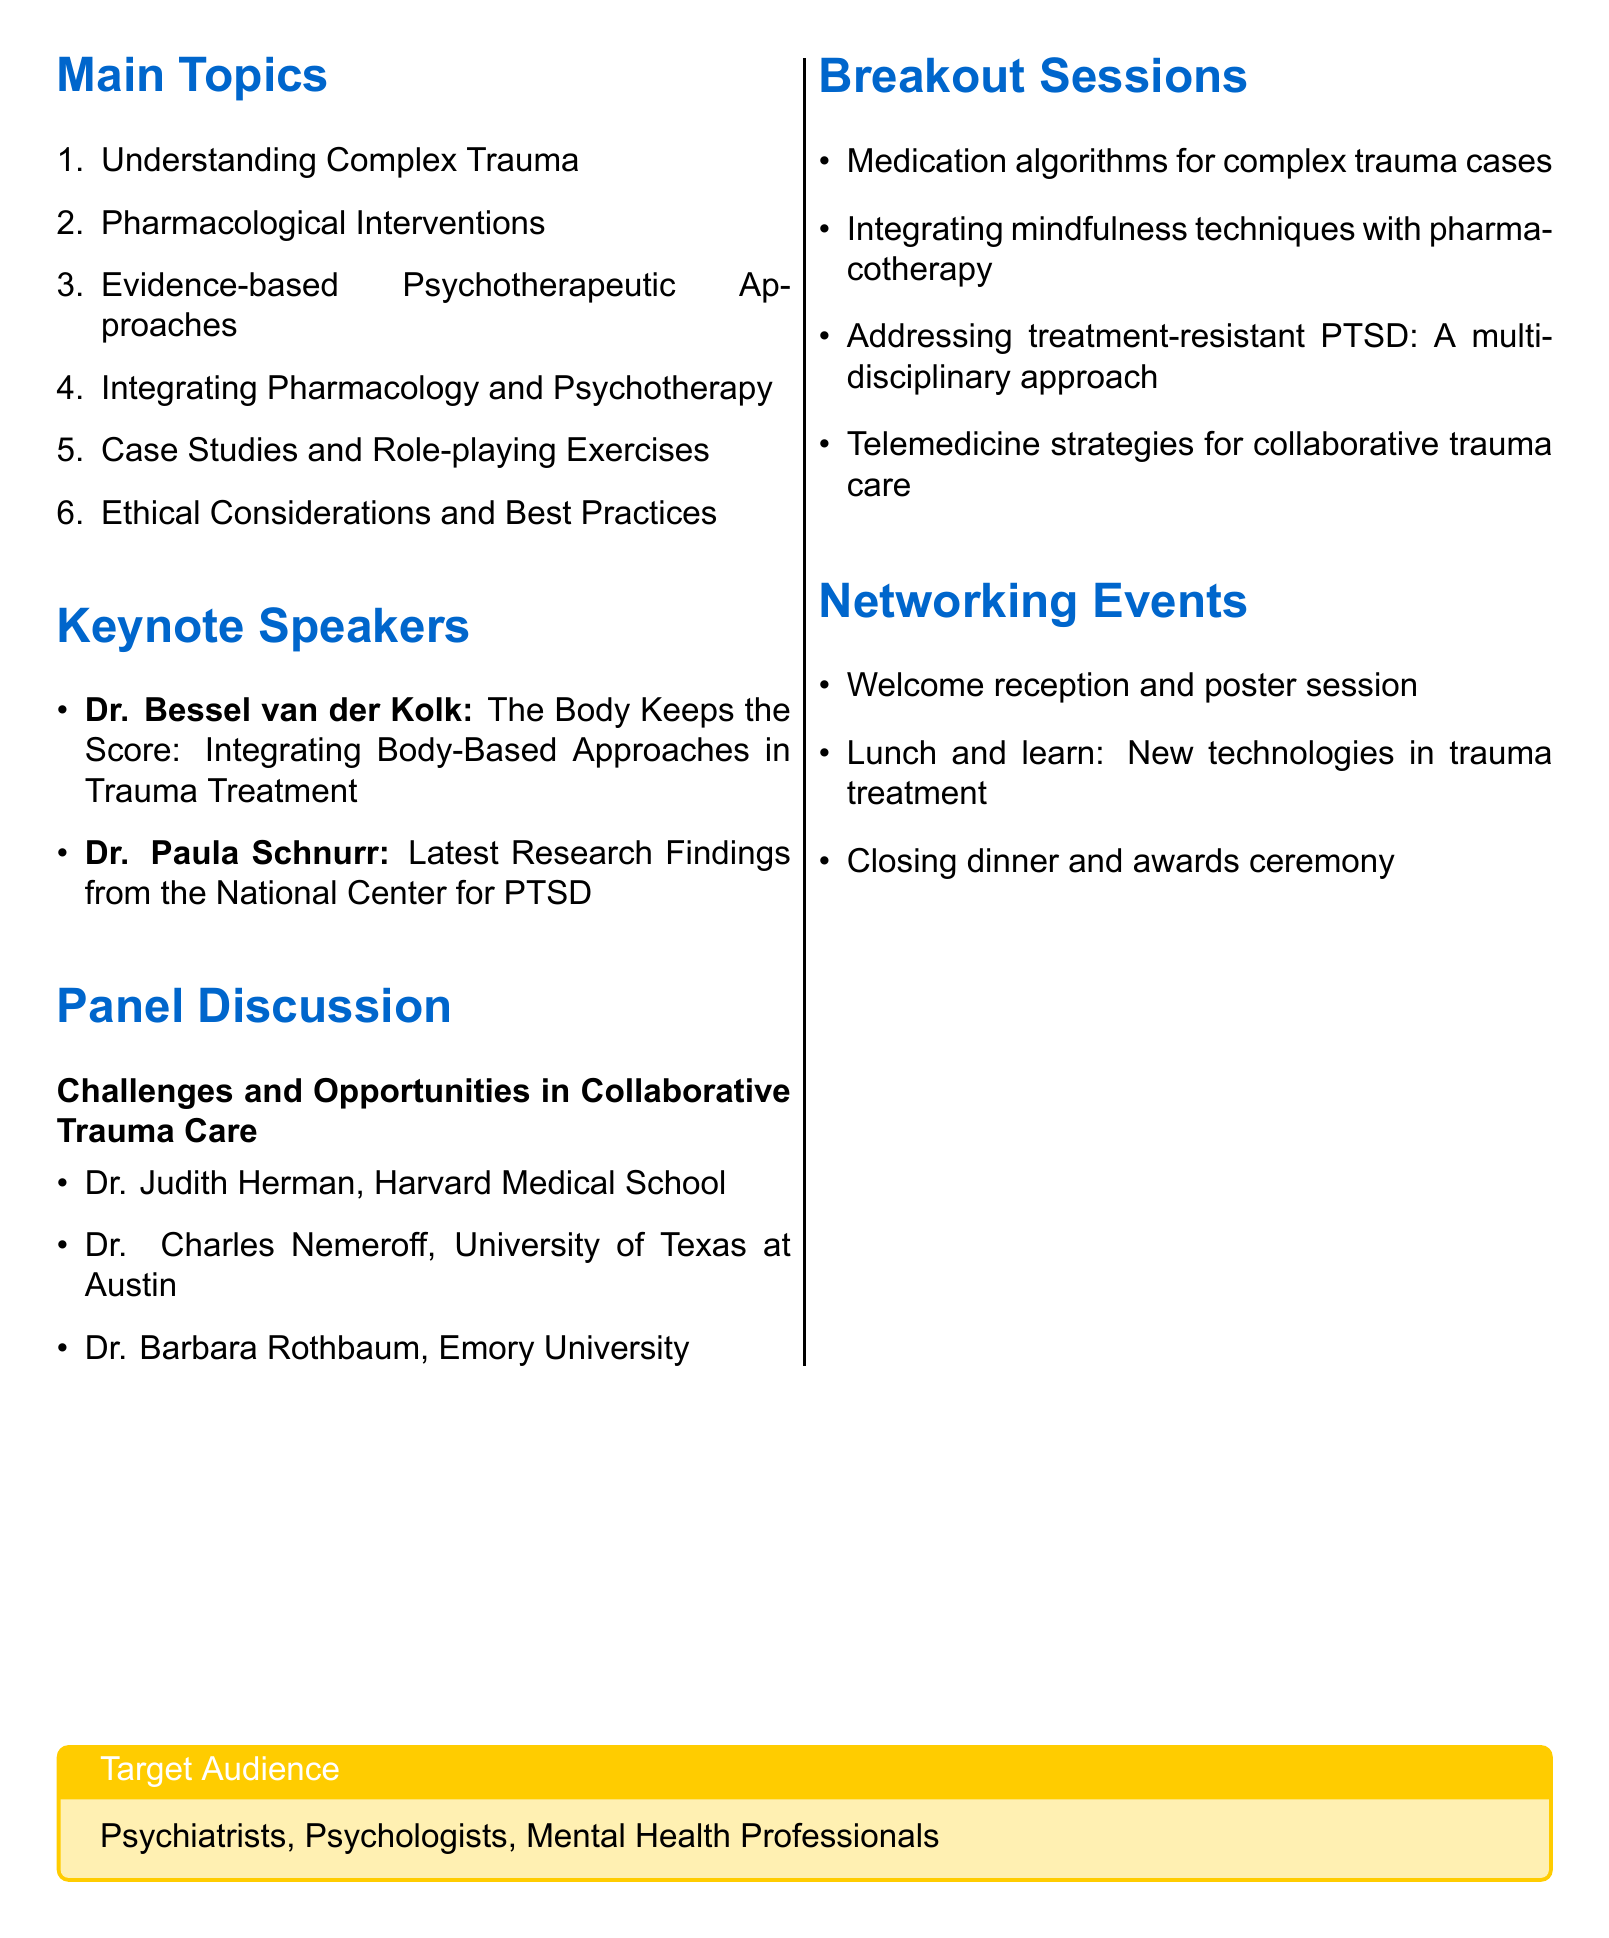What is the title of the workshop? The title is stated at the beginning of the document.
Answer: Integrating Pharmacological and Psychotherapeutic Approaches for Complex Trauma Cases How many days is the workshop? The duration of the workshop is mentioned.
Answer: 2 days Who are the target audience of the workshop? The document specifies the target audience in a designated box.
Answer: Psychiatrists, Psychologists, Mental Health Professionals Name one pharmacological intervention topic. The workshop lists several pharmacological subtopics, of which examples can be found.
Answer: SSRIs and their role in trauma treatment Who is one of the keynote speakers? The document lists keynote speakers and their topics.
Answer: Dr. Bessel van der Kolk What is the theme of the panel discussion? The title of the panel discussion is given in a specific section of the document.
Answer: Challenges and Opportunities in Collaborative Trauma Care What is one of the breakout session topics? The document itemizes breakout sessions where relevant topics are highlighted.
Answer: Medication algorithms for complex trauma cases What is a role-playing exercise topic? The section on Case Studies and Role-playing Exercises lists specific exercises.
Answer: Role-playing: Medication management discussion in therapy sessions What is a networking event mentioned in the agenda? The document describes various networking events taking place during the workshop.
Answer: Welcome reception and poster session What is one ethical consideration discussed? Ethical considerations are outlined under a specific section in the document.
Answer: Informed consent in combined treatment approaches 